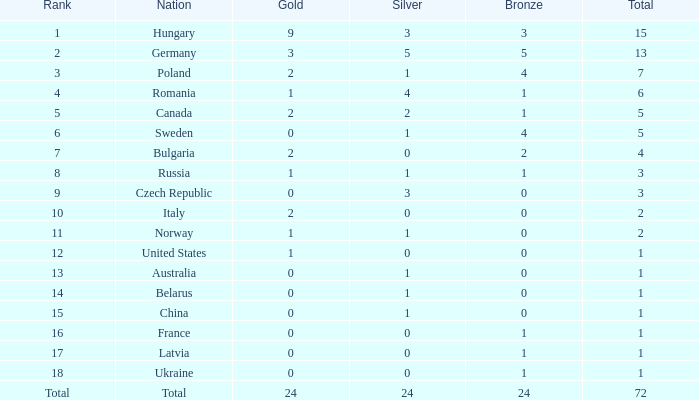How many golds have 3 as the rank, with a total greater than 7? 0.0. Help me parse the entirety of this table. {'header': ['Rank', 'Nation', 'Gold', 'Silver', 'Bronze', 'Total'], 'rows': [['1', 'Hungary', '9', '3', '3', '15'], ['2', 'Germany', '3', '5', '5', '13'], ['3', 'Poland', '2', '1', '4', '7'], ['4', 'Romania', '1', '4', '1', '6'], ['5', 'Canada', '2', '2', '1', '5'], ['6', 'Sweden', '0', '1', '4', '5'], ['7', 'Bulgaria', '2', '0', '2', '4'], ['8', 'Russia', '1', '1', '1', '3'], ['9', 'Czech Republic', '0', '3', '0', '3'], ['10', 'Italy', '2', '0', '0', '2'], ['11', 'Norway', '1', '1', '0', '2'], ['12', 'United States', '1', '0', '0', '1'], ['13', 'Australia', '0', '1', '0', '1'], ['14', 'Belarus', '0', '1', '0', '1'], ['15', 'China', '0', '1', '0', '1'], ['16', 'France', '0', '0', '1', '1'], ['17', 'Latvia', '0', '0', '1', '1'], ['18', 'Ukraine', '0', '0', '1', '1'], ['Total', 'Total', '24', '24', '24', '72']]} 